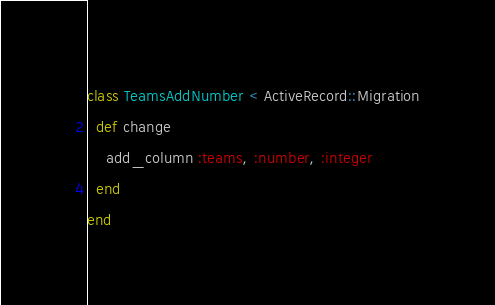Convert code to text. <code><loc_0><loc_0><loc_500><loc_500><_Ruby_>class TeamsAddNumber < ActiveRecord::Migration
  def change
    add_column :teams, :number, :integer
  end
end
</code> 